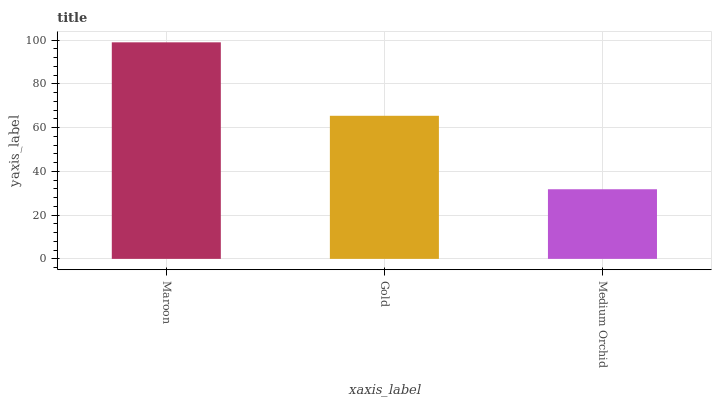Is Medium Orchid the minimum?
Answer yes or no. Yes. Is Maroon the maximum?
Answer yes or no. Yes. Is Gold the minimum?
Answer yes or no. No. Is Gold the maximum?
Answer yes or no. No. Is Maroon greater than Gold?
Answer yes or no. Yes. Is Gold less than Maroon?
Answer yes or no. Yes. Is Gold greater than Maroon?
Answer yes or no. No. Is Maroon less than Gold?
Answer yes or no. No. Is Gold the high median?
Answer yes or no. Yes. Is Gold the low median?
Answer yes or no. Yes. Is Maroon the high median?
Answer yes or no. No. Is Medium Orchid the low median?
Answer yes or no. No. 